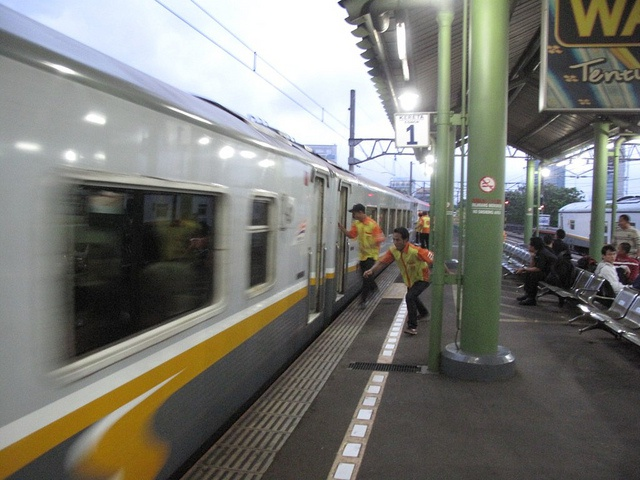Describe the objects in this image and their specific colors. I can see train in lavender, darkgray, black, gray, and olive tones, people in lavender, black, olive, maroon, and gray tones, bench in lavender, gray, black, and darkgray tones, train in lavender, darkgray, and gray tones, and people in lavender, black, gray, and maroon tones in this image. 